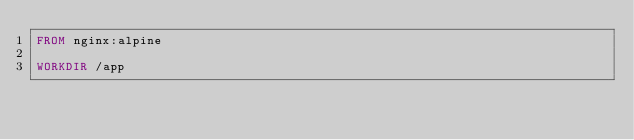<code> <loc_0><loc_0><loc_500><loc_500><_Dockerfile_>FROM nginx:alpine

WORKDIR /app
</code> 